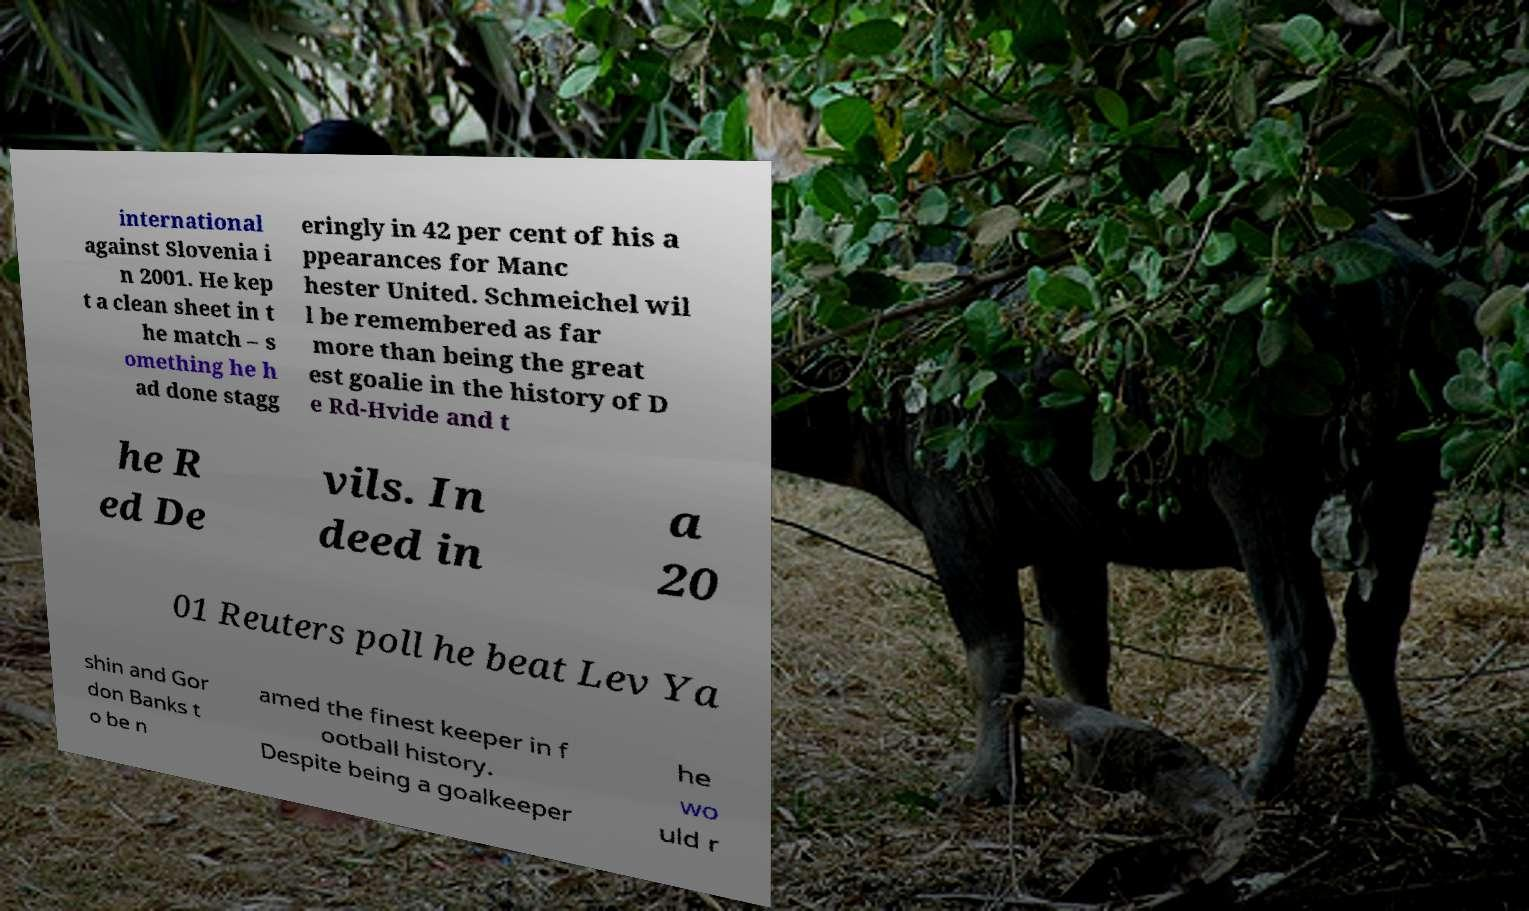Please read and relay the text visible in this image. What does it say? international against Slovenia i n 2001. He kep t a clean sheet in t he match – s omething he h ad done stagg eringly in 42 per cent of his a ppearances for Manc hester United. Schmeichel wil l be remembered as far more than being the great est goalie in the history of D e Rd-Hvide and t he R ed De vils. In deed in a 20 01 Reuters poll he beat Lev Ya shin and Gor don Banks t o be n amed the finest keeper in f ootball history. Despite being a goalkeeper he wo uld r 